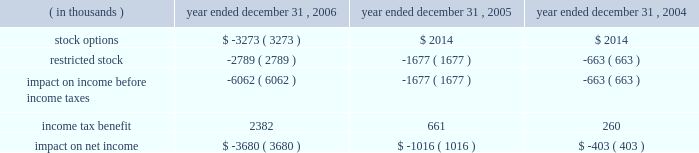Packaging corporation of america notes to consolidated financial statements ( continued ) december 31 , 2006 4 .
Stock-based compensation ( continued ) same period was $ 1988000 lower , than if it had continued to account for share-based compensation under apb no .
25 .
Basic and diluted earnings per share for the year ended december 31 , 2006 were both $ 0.02 lower than if the company had continued to account for share-based compensation under apb no .
25 .
Prior to the adoption of sfas no .
123 ( r ) , the company presented all tax benefits of deductions resulting from share-based payment arrangements as operating cash flows in the statements of cash flows .
Sfas no .
123 ( r ) requires the cash flows resulting from the tax benefits from tax deductions in excess of the compensation cost recognized for those share awards ( excess tax benefits ) to be classified as financing cash flows .
The excess tax benefit of $ 2885000 classified as a financing cash inflow for the year ended december 31 , 2006 would have been classified as an operating cash inflow if the company had not adopted sfas no .
123 ( r ) .
As a result of adopting sfas no 123 ( r ) , unearned compensation previously recorded in stockholders 2019 equity was reclassified against additional paid in capital on january 1 , 2006 .
All stock-based compensation expense not recognized as of december 31 , 2005 and compensation expense related to post 2005 grants of stock options and amortization of restricted stock will be recorded directly to additional paid in capital .
Compensation expense for stock options and restricted stock recognized in the statements of income for the year ended december 31 , 2006 , 2005 and 2004 was as follows : year ended december 31 , ( in thousands ) 2006 2005 2004 .

What was the difference in thousands in impact on net income due to compensation expense for stock options and restricted stock between 2004 and 2005? 
Computations: (1016 - 403)
Answer: 613.0. 